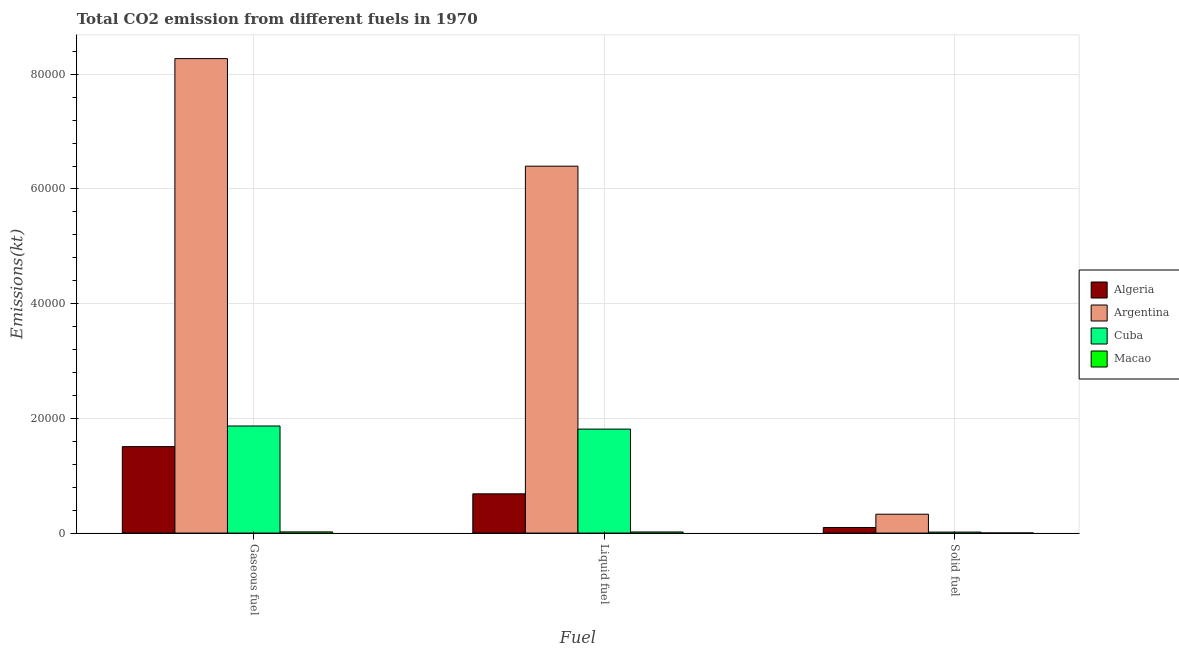How many groups of bars are there?
Offer a terse response. 3. How many bars are there on the 1st tick from the right?
Your response must be concise. 4. What is the label of the 3rd group of bars from the left?
Your answer should be compact. Solid fuel. What is the amount of co2 emissions from liquid fuel in Cuba?
Your answer should be compact. 1.81e+04. Across all countries, what is the maximum amount of co2 emissions from gaseous fuel?
Offer a very short reply. 8.27e+04. Across all countries, what is the minimum amount of co2 emissions from gaseous fuel?
Your answer should be very brief. 205.35. In which country was the amount of co2 emissions from solid fuel maximum?
Offer a terse response. Argentina. In which country was the amount of co2 emissions from solid fuel minimum?
Give a very brief answer. Macao. What is the total amount of co2 emissions from solid fuel in the graph?
Offer a terse response. 4448.07. What is the difference between the amount of co2 emissions from liquid fuel in Macao and that in Cuba?
Offer a terse response. -1.79e+04. What is the difference between the amount of co2 emissions from solid fuel in Algeria and the amount of co2 emissions from gaseous fuel in Cuba?
Make the answer very short. -1.77e+04. What is the average amount of co2 emissions from solid fuel per country?
Give a very brief answer. 1112.02. What is the difference between the amount of co2 emissions from solid fuel and amount of co2 emissions from liquid fuel in Argentina?
Offer a very short reply. -6.07e+04. What is the ratio of the amount of co2 emissions from solid fuel in Algeria to that in Macao?
Make the answer very short. 66.25. Is the amount of co2 emissions from gaseous fuel in Macao less than that in Cuba?
Provide a succinct answer. Yes. Is the difference between the amount of co2 emissions from solid fuel in Macao and Cuba greater than the difference between the amount of co2 emissions from gaseous fuel in Macao and Cuba?
Offer a terse response. Yes. What is the difference between the highest and the second highest amount of co2 emissions from gaseous fuel?
Your response must be concise. 6.41e+04. What is the difference between the highest and the lowest amount of co2 emissions from liquid fuel?
Provide a short and direct response. 6.38e+04. What does the 1st bar from the left in Gaseous fuel represents?
Offer a terse response. Algeria. What does the 4th bar from the right in Liquid fuel represents?
Provide a short and direct response. Algeria. Is it the case that in every country, the sum of the amount of co2 emissions from gaseous fuel and amount of co2 emissions from liquid fuel is greater than the amount of co2 emissions from solid fuel?
Provide a short and direct response. Yes. How many bars are there?
Keep it short and to the point. 12. Are all the bars in the graph horizontal?
Provide a succinct answer. No. What is the difference between two consecutive major ticks on the Y-axis?
Your answer should be compact. 2.00e+04. Are the values on the major ticks of Y-axis written in scientific E-notation?
Ensure brevity in your answer.  No. Does the graph contain any zero values?
Ensure brevity in your answer.  No. Does the graph contain grids?
Keep it short and to the point. Yes. How many legend labels are there?
Offer a terse response. 4. How are the legend labels stacked?
Give a very brief answer. Vertical. What is the title of the graph?
Offer a terse response. Total CO2 emission from different fuels in 1970. What is the label or title of the X-axis?
Your response must be concise. Fuel. What is the label or title of the Y-axis?
Your answer should be very brief. Emissions(kt). What is the Emissions(kt) of Algeria in Gaseous fuel?
Ensure brevity in your answer.  1.51e+04. What is the Emissions(kt) in Argentina in Gaseous fuel?
Keep it short and to the point. 8.27e+04. What is the Emissions(kt) in Cuba in Gaseous fuel?
Ensure brevity in your answer.  1.87e+04. What is the Emissions(kt) of Macao in Gaseous fuel?
Your answer should be very brief. 205.35. What is the Emissions(kt) in Algeria in Liquid fuel?
Keep it short and to the point. 6842.62. What is the Emissions(kt) in Argentina in Liquid fuel?
Your response must be concise. 6.40e+04. What is the Emissions(kt) in Cuba in Liquid fuel?
Your answer should be compact. 1.81e+04. What is the Emissions(kt) of Macao in Liquid fuel?
Give a very brief answer. 194.35. What is the Emissions(kt) in Algeria in Solid fuel?
Your answer should be very brief. 971.75. What is the Emissions(kt) in Argentina in Solid fuel?
Provide a succinct answer. 3289.3. What is the Emissions(kt) of Cuba in Solid fuel?
Offer a very short reply. 172.35. What is the Emissions(kt) of Macao in Solid fuel?
Ensure brevity in your answer.  14.67. Across all Fuel, what is the maximum Emissions(kt) in Algeria?
Give a very brief answer. 1.51e+04. Across all Fuel, what is the maximum Emissions(kt) of Argentina?
Give a very brief answer. 8.27e+04. Across all Fuel, what is the maximum Emissions(kt) in Cuba?
Keep it short and to the point. 1.87e+04. Across all Fuel, what is the maximum Emissions(kt) in Macao?
Your answer should be very brief. 205.35. Across all Fuel, what is the minimum Emissions(kt) of Algeria?
Your answer should be very brief. 971.75. Across all Fuel, what is the minimum Emissions(kt) in Argentina?
Keep it short and to the point. 3289.3. Across all Fuel, what is the minimum Emissions(kt) of Cuba?
Your answer should be compact. 172.35. Across all Fuel, what is the minimum Emissions(kt) of Macao?
Offer a terse response. 14.67. What is the total Emissions(kt) in Algeria in the graph?
Your response must be concise. 2.29e+04. What is the total Emissions(kt) in Argentina in the graph?
Offer a terse response. 1.50e+05. What is the total Emissions(kt) of Cuba in the graph?
Provide a succinct answer. 3.70e+04. What is the total Emissions(kt) in Macao in the graph?
Your response must be concise. 414.37. What is the difference between the Emissions(kt) of Algeria in Gaseous fuel and that in Liquid fuel?
Offer a very short reply. 8232.42. What is the difference between the Emissions(kt) in Argentina in Gaseous fuel and that in Liquid fuel?
Offer a terse response. 1.88e+04. What is the difference between the Emissions(kt) of Cuba in Gaseous fuel and that in Liquid fuel?
Your answer should be compact. 542.72. What is the difference between the Emissions(kt) of Macao in Gaseous fuel and that in Liquid fuel?
Keep it short and to the point. 11. What is the difference between the Emissions(kt) of Algeria in Gaseous fuel and that in Solid fuel?
Provide a succinct answer. 1.41e+04. What is the difference between the Emissions(kt) in Argentina in Gaseous fuel and that in Solid fuel?
Give a very brief answer. 7.94e+04. What is the difference between the Emissions(kt) in Cuba in Gaseous fuel and that in Solid fuel?
Make the answer very short. 1.85e+04. What is the difference between the Emissions(kt) of Macao in Gaseous fuel and that in Solid fuel?
Provide a succinct answer. 190.68. What is the difference between the Emissions(kt) of Algeria in Liquid fuel and that in Solid fuel?
Offer a terse response. 5870.87. What is the difference between the Emissions(kt) of Argentina in Liquid fuel and that in Solid fuel?
Give a very brief answer. 6.07e+04. What is the difference between the Emissions(kt) of Cuba in Liquid fuel and that in Solid fuel?
Your answer should be compact. 1.80e+04. What is the difference between the Emissions(kt) of Macao in Liquid fuel and that in Solid fuel?
Your response must be concise. 179.68. What is the difference between the Emissions(kt) of Algeria in Gaseous fuel and the Emissions(kt) of Argentina in Liquid fuel?
Provide a succinct answer. -4.89e+04. What is the difference between the Emissions(kt) in Algeria in Gaseous fuel and the Emissions(kt) in Cuba in Liquid fuel?
Give a very brief answer. -3054.61. What is the difference between the Emissions(kt) of Algeria in Gaseous fuel and the Emissions(kt) of Macao in Liquid fuel?
Offer a terse response. 1.49e+04. What is the difference between the Emissions(kt) of Argentina in Gaseous fuel and the Emissions(kt) of Cuba in Liquid fuel?
Offer a terse response. 6.46e+04. What is the difference between the Emissions(kt) of Argentina in Gaseous fuel and the Emissions(kt) of Macao in Liquid fuel?
Provide a short and direct response. 8.25e+04. What is the difference between the Emissions(kt) in Cuba in Gaseous fuel and the Emissions(kt) in Macao in Liquid fuel?
Offer a terse response. 1.85e+04. What is the difference between the Emissions(kt) of Algeria in Gaseous fuel and the Emissions(kt) of Argentina in Solid fuel?
Offer a very short reply. 1.18e+04. What is the difference between the Emissions(kt) of Algeria in Gaseous fuel and the Emissions(kt) of Cuba in Solid fuel?
Your response must be concise. 1.49e+04. What is the difference between the Emissions(kt) of Algeria in Gaseous fuel and the Emissions(kt) of Macao in Solid fuel?
Offer a very short reply. 1.51e+04. What is the difference between the Emissions(kt) in Argentina in Gaseous fuel and the Emissions(kt) in Cuba in Solid fuel?
Provide a short and direct response. 8.26e+04. What is the difference between the Emissions(kt) in Argentina in Gaseous fuel and the Emissions(kt) in Macao in Solid fuel?
Offer a terse response. 8.27e+04. What is the difference between the Emissions(kt) of Cuba in Gaseous fuel and the Emissions(kt) of Macao in Solid fuel?
Give a very brief answer. 1.87e+04. What is the difference between the Emissions(kt) in Algeria in Liquid fuel and the Emissions(kt) in Argentina in Solid fuel?
Ensure brevity in your answer.  3553.32. What is the difference between the Emissions(kt) of Algeria in Liquid fuel and the Emissions(kt) of Cuba in Solid fuel?
Your answer should be compact. 6670.27. What is the difference between the Emissions(kt) of Algeria in Liquid fuel and the Emissions(kt) of Macao in Solid fuel?
Ensure brevity in your answer.  6827.95. What is the difference between the Emissions(kt) in Argentina in Liquid fuel and the Emissions(kt) in Cuba in Solid fuel?
Provide a succinct answer. 6.38e+04. What is the difference between the Emissions(kt) of Argentina in Liquid fuel and the Emissions(kt) of Macao in Solid fuel?
Your answer should be very brief. 6.40e+04. What is the difference between the Emissions(kt) of Cuba in Liquid fuel and the Emissions(kt) of Macao in Solid fuel?
Ensure brevity in your answer.  1.81e+04. What is the average Emissions(kt) in Algeria per Fuel?
Your response must be concise. 7629.8. What is the average Emissions(kt) of Argentina per Fuel?
Offer a terse response. 5.00e+04. What is the average Emissions(kt) of Cuba per Fuel?
Ensure brevity in your answer.  1.23e+04. What is the average Emissions(kt) in Macao per Fuel?
Keep it short and to the point. 138.12. What is the difference between the Emissions(kt) in Algeria and Emissions(kt) in Argentina in Gaseous fuel?
Your response must be concise. -6.77e+04. What is the difference between the Emissions(kt) in Algeria and Emissions(kt) in Cuba in Gaseous fuel?
Make the answer very short. -3597.33. What is the difference between the Emissions(kt) in Algeria and Emissions(kt) in Macao in Gaseous fuel?
Your answer should be very brief. 1.49e+04. What is the difference between the Emissions(kt) of Argentina and Emissions(kt) of Cuba in Gaseous fuel?
Give a very brief answer. 6.41e+04. What is the difference between the Emissions(kt) in Argentina and Emissions(kt) in Macao in Gaseous fuel?
Provide a short and direct response. 8.25e+04. What is the difference between the Emissions(kt) of Cuba and Emissions(kt) of Macao in Gaseous fuel?
Ensure brevity in your answer.  1.85e+04. What is the difference between the Emissions(kt) of Algeria and Emissions(kt) of Argentina in Liquid fuel?
Ensure brevity in your answer.  -5.71e+04. What is the difference between the Emissions(kt) of Algeria and Emissions(kt) of Cuba in Liquid fuel?
Provide a succinct answer. -1.13e+04. What is the difference between the Emissions(kt) in Algeria and Emissions(kt) in Macao in Liquid fuel?
Offer a terse response. 6648.27. What is the difference between the Emissions(kt) of Argentina and Emissions(kt) of Cuba in Liquid fuel?
Offer a very short reply. 4.58e+04. What is the difference between the Emissions(kt) in Argentina and Emissions(kt) in Macao in Liquid fuel?
Keep it short and to the point. 6.38e+04. What is the difference between the Emissions(kt) in Cuba and Emissions(kt) in Macao in Liquid fuel?
Your response must be concise. 1.79e+04. What is the difference between the Emissions(kt) of Algeria and Emissions(kt) of Argentina in Solid fuel?
Offer a terse response. -2317.54. What is the difference between the Emissions(kt) in Algeria and Emissions(kt) in Cuba in Solid fuel?
Offer a terse response. 799.41. What is the difference between the Emissions(kt) of Algeria and Emissions(kt) of Macao in Solid fuel?
Your answer should be compact. 957.09. What is the difference between the Emissions(kt) in Argentina and Emissions(kt) in Cuba in Solid fuel?
Make the answer very short. 3116.95. What is the difference between the Emissions(kt) in Argentina and Emissions(kt) in Macao in Solid fuel?
Ensure brevity in your answer.  3274.63. What is the difference between the Emissions(kt) of Cuba and Emissions(kt) of Macao in Solid fuel?
Ensure brevity in your answer.  157.68. What is the ratio of the Emissions(kt) in Algeria in Gaseous fuel to that in Liquid fuel?
Keep it short and to the point. 2.2. What is the ratio of the Emissions(kt) in Argentina in Gaseous fuel to that in Liquid fuel?
Your answer should be compact. 1.29. What is the ratio of the Emissions(kt) in Cuba in Gaseous fuel to that in Liquid fuel?
Provide a short and direct response. 1.03. What is the ratio of the Emissions(kt) in Macao in Gaseous fuel to that in Liquid fuel?
Make the answer very short. 1.06. What is the ratio of the Emissions(kt) of Algeria in Gaseous fuel to that in Solid fuel?
Your response must be concise. 15.51. What is the ratio of the Emissions(kt) of Argentina in Gaseous fuel to that in Solid fuel?
Keep it short and to the point. 25.15. What is the ratio of the Emissions(kt) in Cuba in Gaseous fuel to that in Solid fuel?
Provide a succinct answer. 108.34. What is the ratio of the Emissions(kt) in Algeria in Liquid fuel to that in Solid fuel?
Provide a succinct answer. 7.04. What is the ratio of the Emissions(kt) in Argentina in Liquid fuel to that in Solid fuel?
Your response must be concise. 19.45. What is the ratio of the Emissions(kt) in Cuba in Liquid fuel to that in Solid fuel?
Offer a very short reply. 105.19. What is the ratio of the Emissions(kt) in Macao in Liquid fuel to that in Solid fuel?
Offer a very short reply. 13.25. What is the difference between the highest and the second highest Emissions(kt) in Algeria?
Provide a succinct answer. 8232.42. What is the difference between the highest and the second highest Emissions(kt) of Argentina?
Provide a short and direct response. 1.88e+04. What is the difference between the highest and the second highest Emissions(kt) in Cuba?
Provide a short and direct response. 542.72. What is the difference between the highest and the second highest Emissions(kt) in Macao?
Provide a short and direct response. 11. What is the difference between the highest and the lowest Emissions(kt) of Algeria?
Give a very brief answer. 1.41e+04. What is the difference between the highest and the lowest Emissions(kt) of Argentina?
Your answer should be compact. 7.94e+04. What is the difference between the highest and the lowest Emissions(kt) of Cuba?
Your answer should be compact. 1.85e+04. What is the difference between the highest and the lowest Emissions(kt) of Macao?
Offer a very short reply. 190.68. 